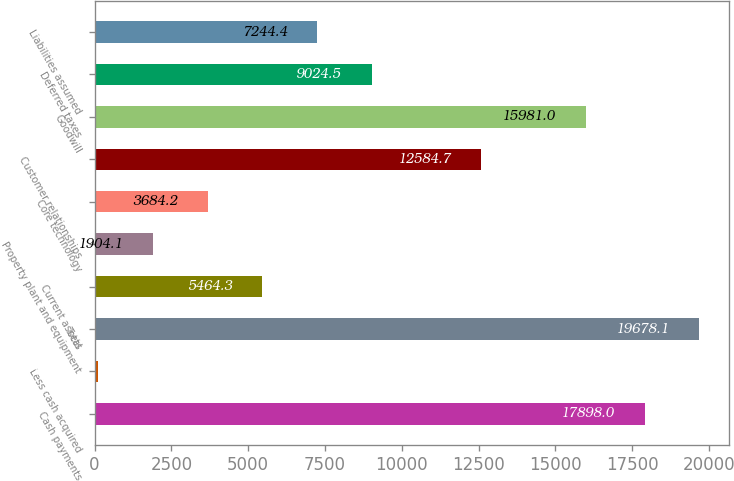Convert chart to OTSL. <chart><loc_0><loc_0><loc_500><loc_500><bar_chart><fcel>Cash payments<fcel>Less cash acquired<fcel>Total<fcel>Current assets<fcel>Property plant and equipment<fcel>Core technology<fcel>Customer relationships<fcel>Goodwill<fcel>Deferred taxes<fcel>Liabilities assumed<nl><fcel>17898<fcel>124<fcel>19678.1<fcel>5464.3<fcel>1904.1<fcel>3684.2<fcel>12584.7<fcel>15981<fcel>9024.5<fcel>7244.4<nl></chart> 